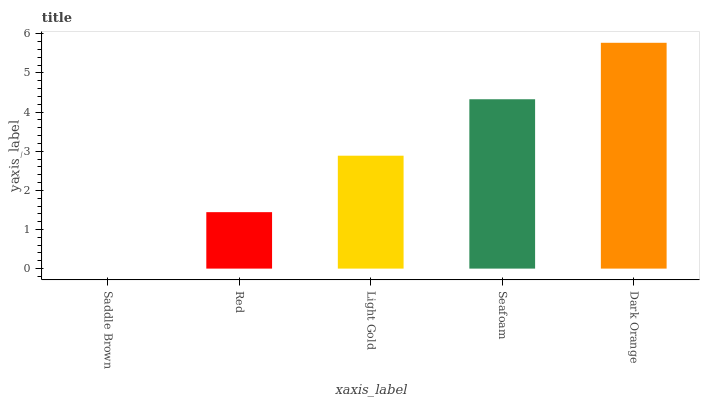Is Red the minimum?
Answer yes or no. No. Is Red the maximum?
Answer yes or no. No. Is Red greater than Saddle Brown?
Answer yes or no. Yes. Is Saddle Brown less than Red?
Answer yes or no. Yes. Is Saddle Brown greater than Red?
Answer yes or no. No. Is Red less than Saddle Brown?
Answer yes or no. No. Is Light Gold the high median?
Answer yes or no. Yes. Is Light Gold the low median?
Answer yes or no. Yes. Is Saddle Brown the high median?
Answer yes or no. No. Is Saddle Brown the low median?
Answer yes or no. No. 